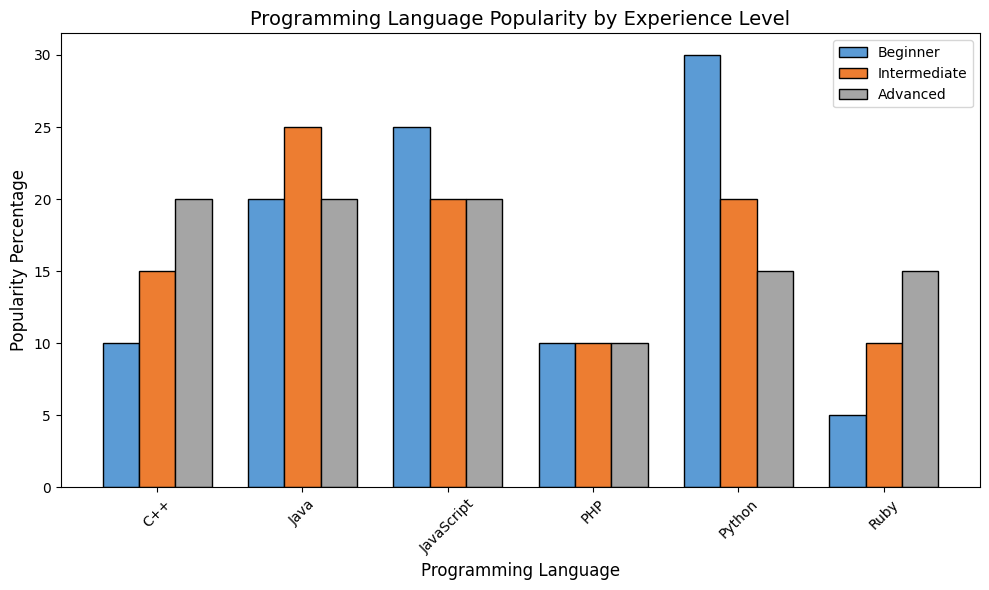Which programming language is the most popular among beginners? Look at the heights of the bars for beginners. The highest bar is for Python.
Answer: Python Among intermediate and advanced users, which programming language has the same popularity percentage? Check the bars for intermediate and advanced users. Both JavaScript and PHP have the same height for both experience levels.
Answer: JavaScript and PHP What is the total popularity percentage of C++ across all experience levels? Sum the heights of the C++ bars for beginner, intermediate, and advanced levels. C++ has (10 + 15 + 20 = 45) percent popularity.
Answer: 45% Which experience level prefers Ruby the least? Compare the height of the Ruby bars across all experience levels. The bar for beginners is the shortest.
Answer: Beginner What is the difference in Python's popularity percentage between beginners and advanced users? Subtract the height of the Python bar for advanced users from the height for beginners. (30 - 15 = 15) percent.
Answer: 15% For intermediate users, which programming language has the highest popularity percentage? Look at the heights of the bars for intermediate users. The highest bar is for Java.
Answer: Java Compare the popularity of PHP between beginners and intermediates. Which group shows greater interest? Compare the heights of the PHP bars for beginners and intermediates. Both are of equal height.
Answer: Equal What is the average popularity percentage of JavaScript across all experience levels? Sum the percentages of JavaScript for all experience levels and divide by the number of experience levels. (25 + 20 + 20) / 3 = 21.67 percent.
Answer: 21.67% Which programming language has the most consistent popularity across all experience levels? Find the programming language whose bars are most similar in height. PHP's bars are the most consistent at 10 percent each.
Answer: PHP Between beginners and advanced users, which group has a higher average popularity percentage across all programming languages? Calculate the average for each group: (30+20+25+10+5+10)/6 = 16.67 for beginners and (15+20+20+20+15+10)/6 = 16.67 for advanced users. Both groups have the same average.
Answer: Equal 